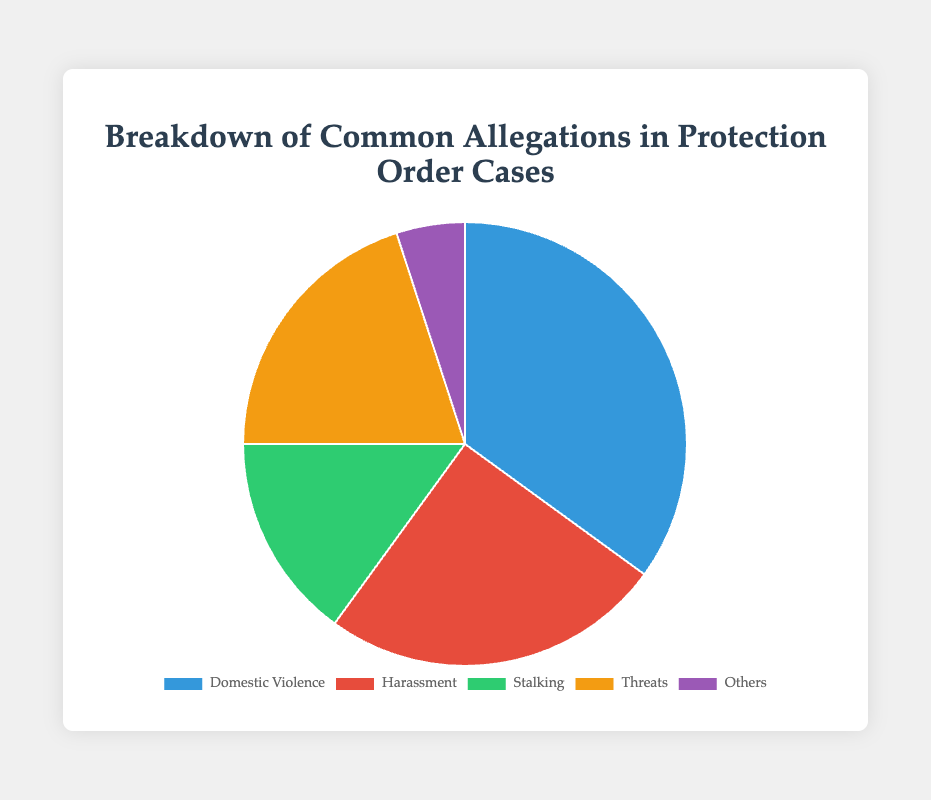What is the largest category of allegations in protection order cases? The largest category can be identified by looking at the section of the pie chart that takes up the most space. Here, Domestic Violence occupies 35% which is the largest portion.
Answer: Domestic Violence Which allegation category is the smallest? The smallest category can be identified by the section of the pie chart that takes up the least space. Here, Others occupies 5% which is the smallest portion.
Answer: Others How much larger is the percentage of Domestic Violence allegations compared to Stalking? The percentage of Domestic Violence allegations is 35%, and for Stalking, it's 15%. To find how much larger, subtract 15 from 35. 35% - 15% = 20%.
Answer: 20% What is the combined percentage for Harassment and Threats allegations? Harassment makes up 25% and Threats comprise 20%. Add these percentages to get the combined percentage. 25% + 20% = 45%.
Answer: 45% Compare the percentages of Domestic Violence and Harassment. Which is greater and by how much? Domestic Violence is 35% and Harassment is 25%. Subtract 25 from 35 to find the difference. 35% - 25% = 10%.
Answer: Domestic Violence by 10% Which two categories combined form the majority of the pie chart? To find the majority, we need a combined percentage greater than 50%. Domestic Violence (35%) and Harassment (25%) together make 60%. So they form the majority.
Answer: Domestic Violence and Harassment How many more times is the percentage of Domestic Violence compared to Others? Domestic Violence is 35% and Others is 5%. To find how many more times, divide 35 by 5. 35 / 5 = 7.
Answer: 7 times If allegations classified under 'Others' doubled, what would be the new percentage for 'Others'? The current percentage for Others is 5%. Doubling it would be 5% * 2 = 10%.
Answer: 10% Which two categories exhibit the closest percentages and what is their difference? Harassment is 25% and Threats are 20%. The difference between them is 5%.
Answer: Harassment and Threats, 5% What percentage of allegations do not fall under Domestic Violence or Harassment? Calculate the sum of Domestic Violence (35%) and Harassment (25%) which is 60%. Subtract this from 100%. 100% - 60% = 40%.
Answer: 40% 